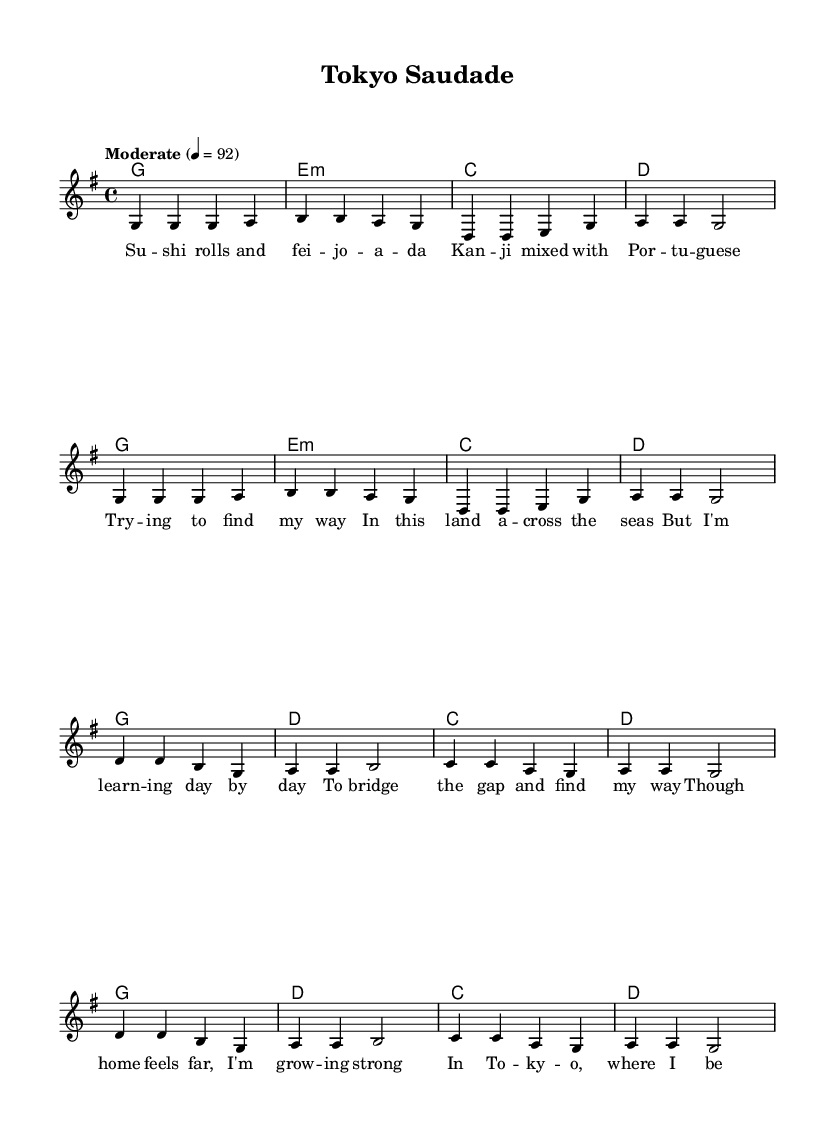What is the key signature of this music? The key signature indicates that the piece is in G major, which has one sharp (F sharp).
Answer: G major What is the time signature of this music? The time signature is found at the beginning of the staff and indicates that there are four beats per measure, which is represented as 4/4.
Answer: 4/4 What is the tempo marking for this piece? The tempo marking is located at the beginning and indicates a moderate speed of 92 beats per minute.
Answer: Moderate 92 How many measures are in the verse section? By counting the groupings of bars for the verse, we see there are eight measures in the verse section.
Answer: Eight What is the chord progression used in the verse section? The chord progression can be identified by looking at the chord symbols above the melody; it progresses from G major to E minor, C major, and D major.
Answer: G, E minor, C, D What is the lyrical theme of the chorus? Analyzing the lyrics, the theme revolves around overcoming homesickness and learning to adapt in a new place, which draws from the emotional resonance typical in country music.
Answer: Overcoming homesickness Which lines contain references to language barriers? Reviewing the lyrics shows that the references to language barriers are explicitly in the first verse, highlighting the struggle with kanji and Portuguese.
Answer: First verse 